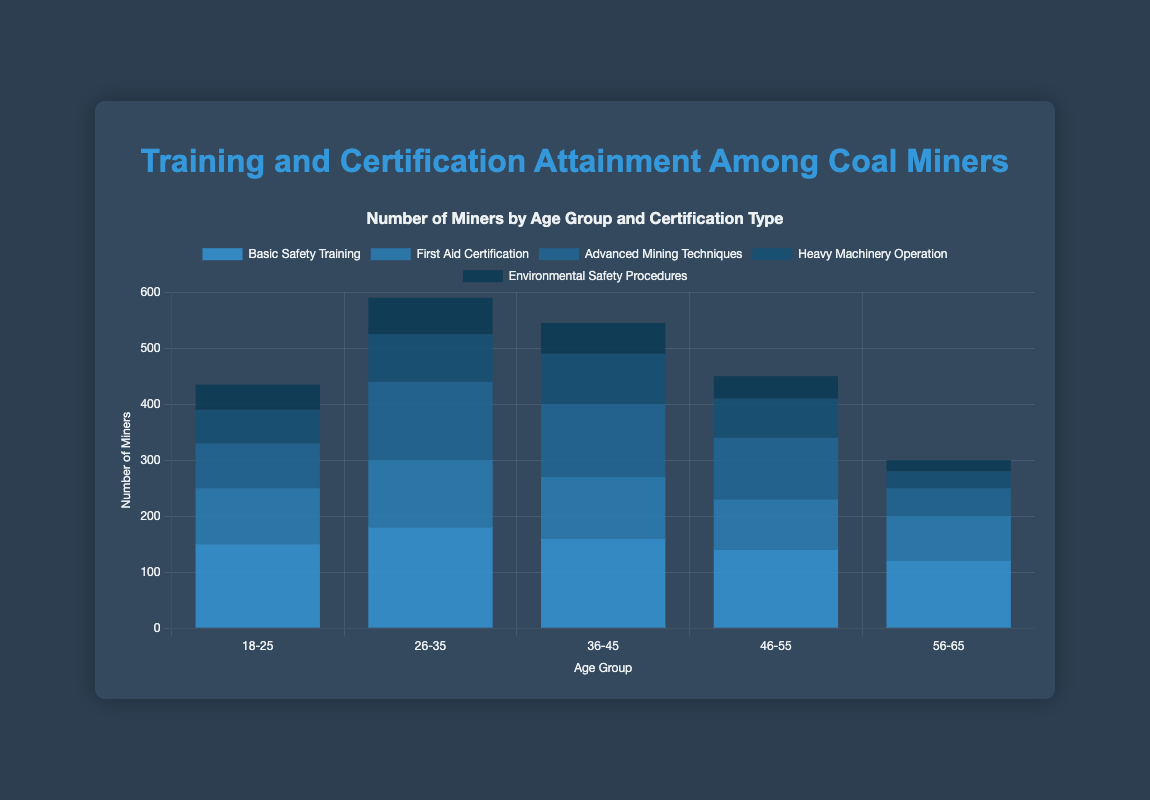What's the total number of miners who have obtained Basic Safety Training in all age groups? Sum up the numbers for Basic Safety Training across all age groups: 150 (18-25) + 180 (26-35) + 160 (36-45) + 140 (46-55) + 120 (56-65) = 750
Answer: 750 Which age group has the highest number of miners with Advanced Mining Techniques certification? Compare the numbers for Advanced Mining Techniques certification across all age groups: 80 (18-25), 140 (26-35), 130 (36-45), 110 (46-55), 50 (56-65). Clearly, the 26-35 age group has the highest number, which is 140
Answer: 26-35 In the 46-55 age group, do more miners have First Aid Certification or Heavy Machinery Operation certification? Compare the numbers for the 46-55 age group: First Aid Certification (90) and Heavy Machinery Operation (70). The number for First Aid Certification is higher
Answer: First Aid Certification What is the color used to represent Environmental Safety Procedures in the bar chart? Environmental Safety Procedures is visually represented by the bars shaded in a very dark blue color
Answer: dark blue What's the total number of certifications attained by miners in the 56-65 age group across all categories? Sum up the numbers for the 56-65 age group: Basic Safety Training (120) + First Aid Certification (80) + Advanced Mining Techniques (50) + Heavy Machinery Operation (30) + Environmental Safety Procedures (20). This results in 300
Answer: 300 Compare the number of miners who have obtained Basic Safety Training and those who have obtained First Aid Certification in the 26-35 age group. Which is higher? Compare the numbers for the 26-35 age group: Basic Safety Training (180) is higher than First Aid Certification (120)
Answer: Basic Safety Training Which age group has the lowest number of miners with Heavy Machinery Operation certification? Compare Heavy Machinery Operation certification numbers across all age groups: 60 (18-25), 85 (26-35), 90 (36-45), 70 (46-55), 30 (56-65). The lowest number is for the 56-65 age group, which is 30
Answer: 56-65 How many more miners in the 36-45 age group have Advanced Mining Techniques certification compared to the 18-25 age group? Subtract the number of miners with Advanced Mining Techniques certification in the 18-25 age group (80) from the number in the 36-45 age group (130). The difference is 130 - 80 = 50
Answer: 50 